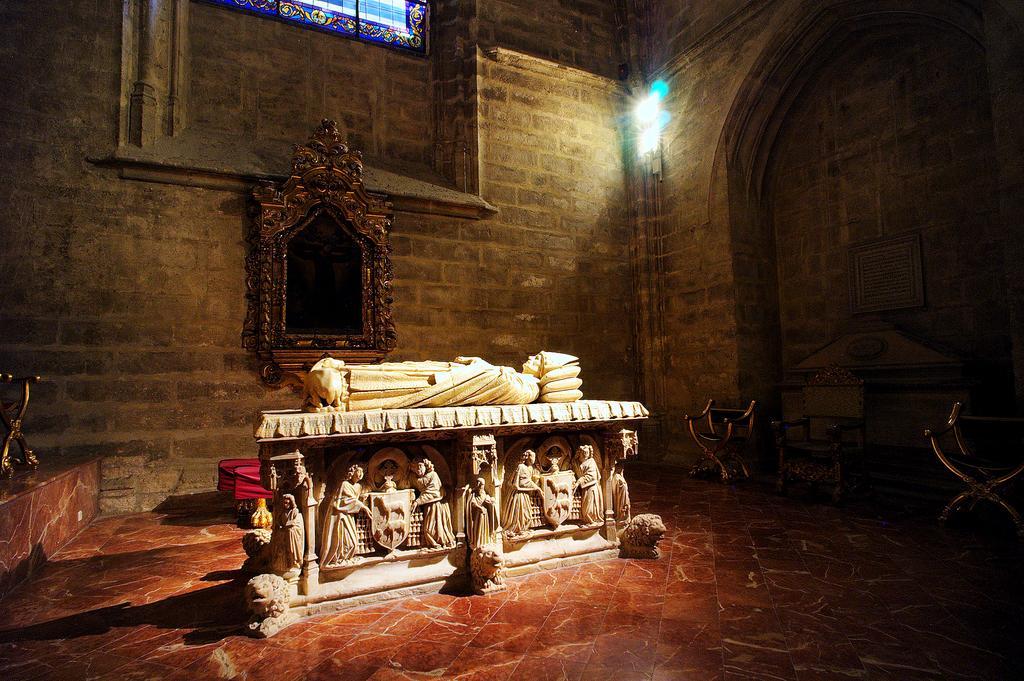How would you summarize this image in a sentence or two? In the center of the image there are sculptures. Behind the sculptures there are some objects. In the background of the image there is a photo frame and a mirror on the wall. There are lights. On the right side of the image there are chairs. On the left side of the image there is some object on the platform. At the bottom of the image there is a floor. 